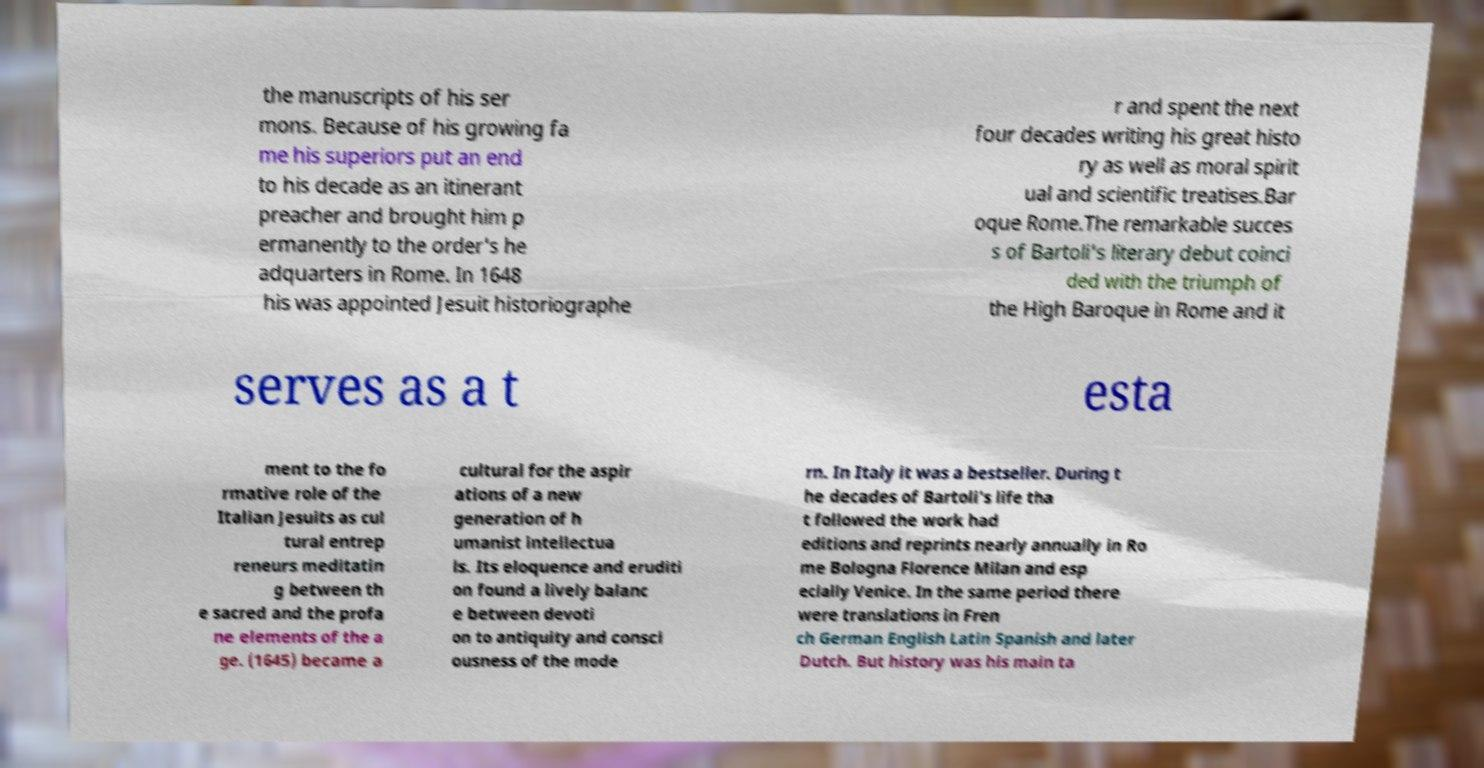What messages or text are displayed in this image? I need them in a readable, typed format. the manuscripts of his ser mons. Because of his growing fa me his superiors put an end to his decade as an itinerant preacher and brought him p ermanently to the order's he adquarters in Rome. In 1648 his was appointed Jesuit historiographe r and spent the next four decades writing his great histo ry as well as moral spirit ual and scientific treatises.Bar oque Rome.The remarkable succes s of Bartoli's literary debut coinci ded with the triumph of the High Baroque in Rome and it serves as a t esta ment to the fo rmative role of the Italian Jesuits as cul tural entrep reneurs meditatin g between th e sacred and the profa ne elements of the a ge. (1645) became a cultural for the aspir ations of a new generation of h umanist intellectua ls. Its eloquence and eruditi on found a lively balanc e between devoti on to antiquity and consci ousness of the mode rn. In Italy it was a bestseller. During t he decades of Bartoli's life tha t followed the work had editions and reprints nearly annually in Ro me Bologna Florence Milan and esp ecially Venice. In the same period there were translations in Fren ch German English Latin Spanish and later Dutch. But history was his main ta 